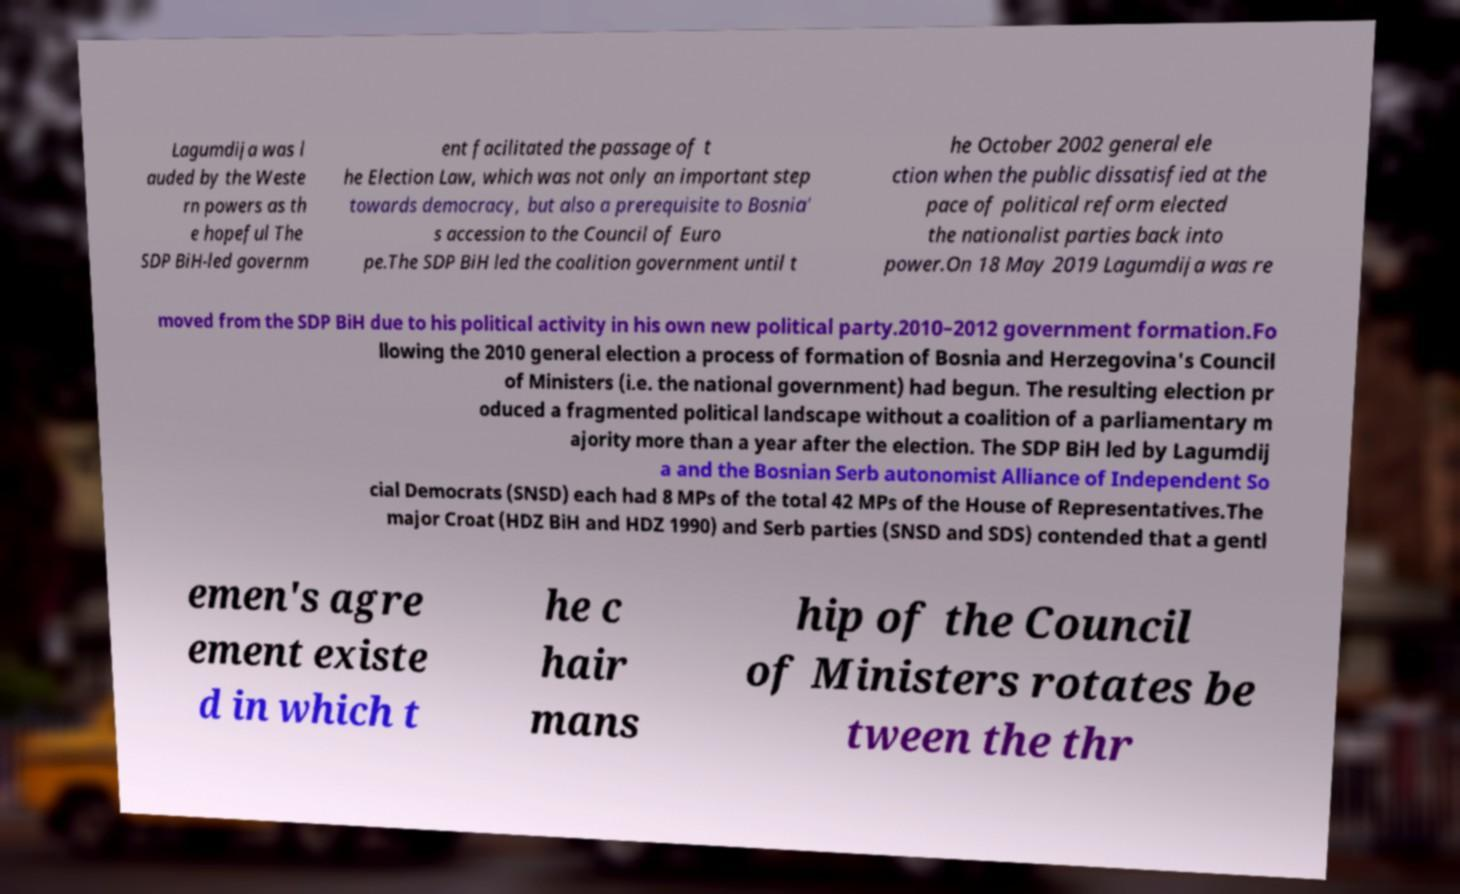There's text embedded in this image that I need extracted. Can you transcribe it verbatim? Lagumdija was l auded by the Weste rn powers as th e hopeful The SDP BiH-led governm ent facilitated the passage of t he Election Law, which was not only an important step towards democracy, but also a prerequisite to Bosnia' s accession to the Council of Euro pe.The SDP BiH led the coalition government until t he October 2002 general ele ction when the public dissatisfied at the pace of political reform elected the nationalist parties back into power.On 18 May 2019 Lagumdija was re moved from the SDP BiH due to his political activity in his own new political party.2010–2012 government formation.Fo llowing the 2010 general election a process of formation of Bosnia and Herzegovina's Council of Ministers (i.e. the national government) had begun. The resulting election pr oduced a fragmented political landscape without a coalition of a parliamentary m ajority more than a year after the election. The SDP BiH led by Lagumdij a and the Bosnian Serb autonomist Alliance of Independent So cial Democrats (SNSD) each had 8 MPs of the total 42 MPs of the House of Representatives.The major Croat (HDZ BiH and HDZ 1990) and Serb parties (SNSD and SDS) contended that a gentl emen's agre ement existe d in which t he c hair mans hip of the Council of Ministers rotates be tween the thr 